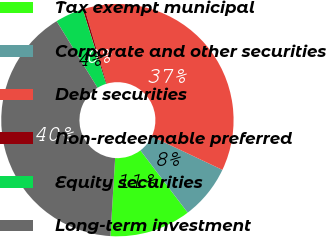<chart> <loc_0><loc_0><loc_500><loc_500><pie_chart><fcel>Tax exempt municipal<fcel>Corporate and other securities<fcel>Debt securities<fcel>Non-redeemable preferred<fcel>Equity securities<fcel>Long-term investment<nl><fcel>11.3%<fcel>7.62%<fcel>36.6%<fcel>0.27%<fcel>3.94%<fcel>40.27%<nl></chart> 